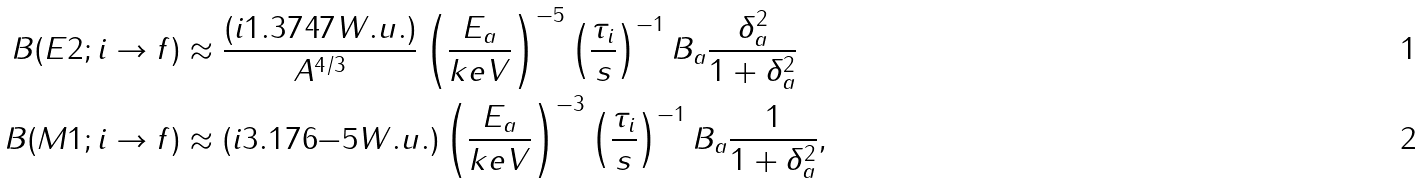Convert formula to latex. <formula><loc_0><loc_0><loc_500><loc_500>B ( E 2 ; { i \rightarrow f } ) & \approx \frac { ( i { 1 . 3 7 4 } { 7 } W . u . ) } { A ^ { 4 / 3 } } \left ( \frac { E _ { a } } { k e V } \right ) ^ { - 5 } \left ( \frac { \tau _ { i } } { s } \right ) ^ { - 1 } B _ { a } \frac { \delta _ { a } ^ { 2 } } { 1 + \delta _ { a } ^ { 2 } } \\ B ( M 1 ; { i \rightarrow f } ) & \approx ( i { 3 . 1 7 6 } { - 5 } W . u . ) \left ( \frac { E _ { a } } { k e V } \right ) ^ { - 3 } \left ( \frac { \tau _ { i } } { s } \right ) ^ { - 1 } B _ { a } \frac { 1 } { 1 + \delta _ { a } ^ { 2 } } ,</formula> 